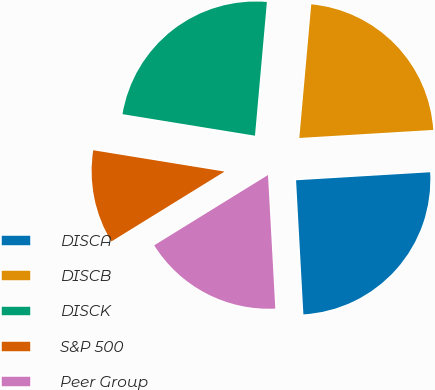Convert chart to OTSL. <chart><loc_0><loc_0><loc_500><loc_500><pie_chart><fcel>DISCA<fcel>DISCB<fcel>DISCK<fcel>S&P 500<fcel>Peer Group<nl><fcel>25.08%<fcel>22.63%<fcel>23.85%<fcel>11.37%<fcel>17.06%<nl></chart> 